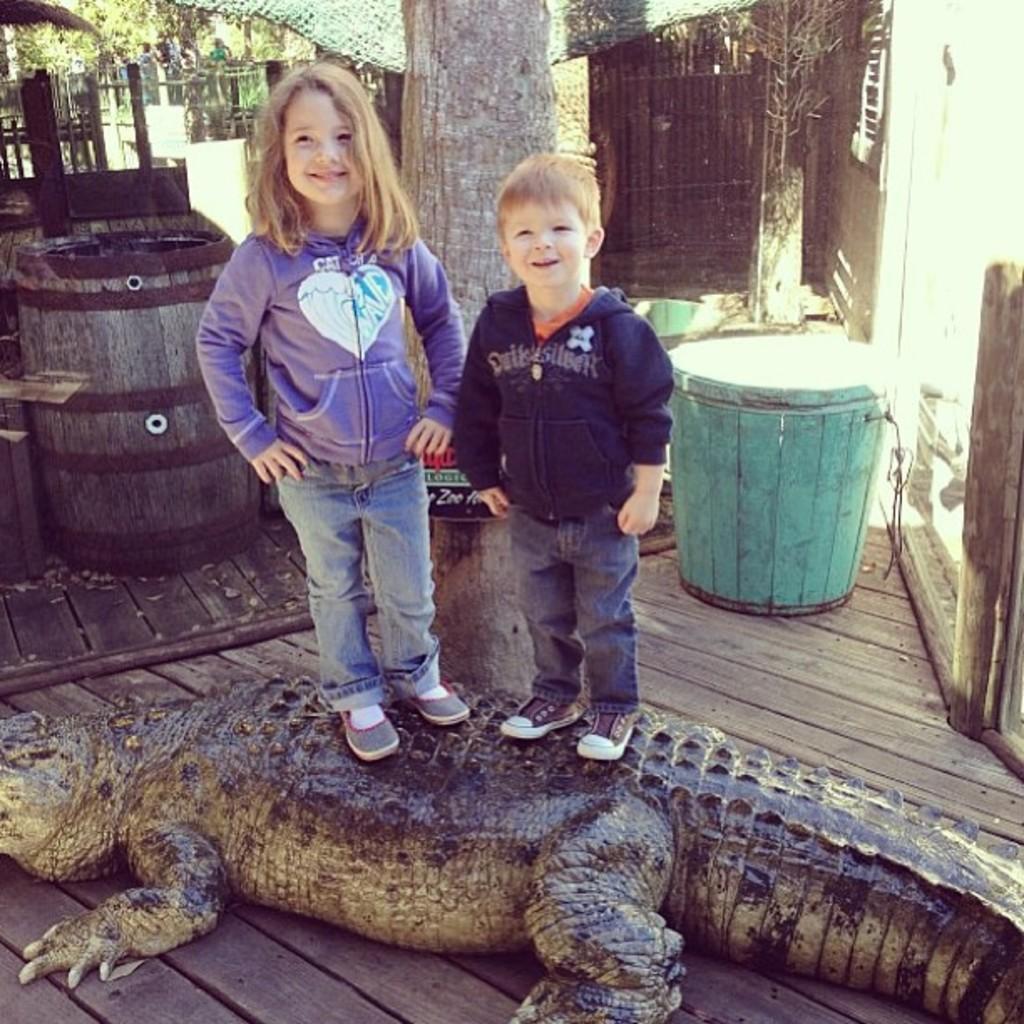Could you give a brief overview of what you see in this image? In this image I can see the floor which is made of wood and on it I can see a crocodile which is brown and black in color and on the crocodile I can see two children wearing jackets and jeans are standing. In the background I can see a barrel, few trees, a green colored object and few other objects. 